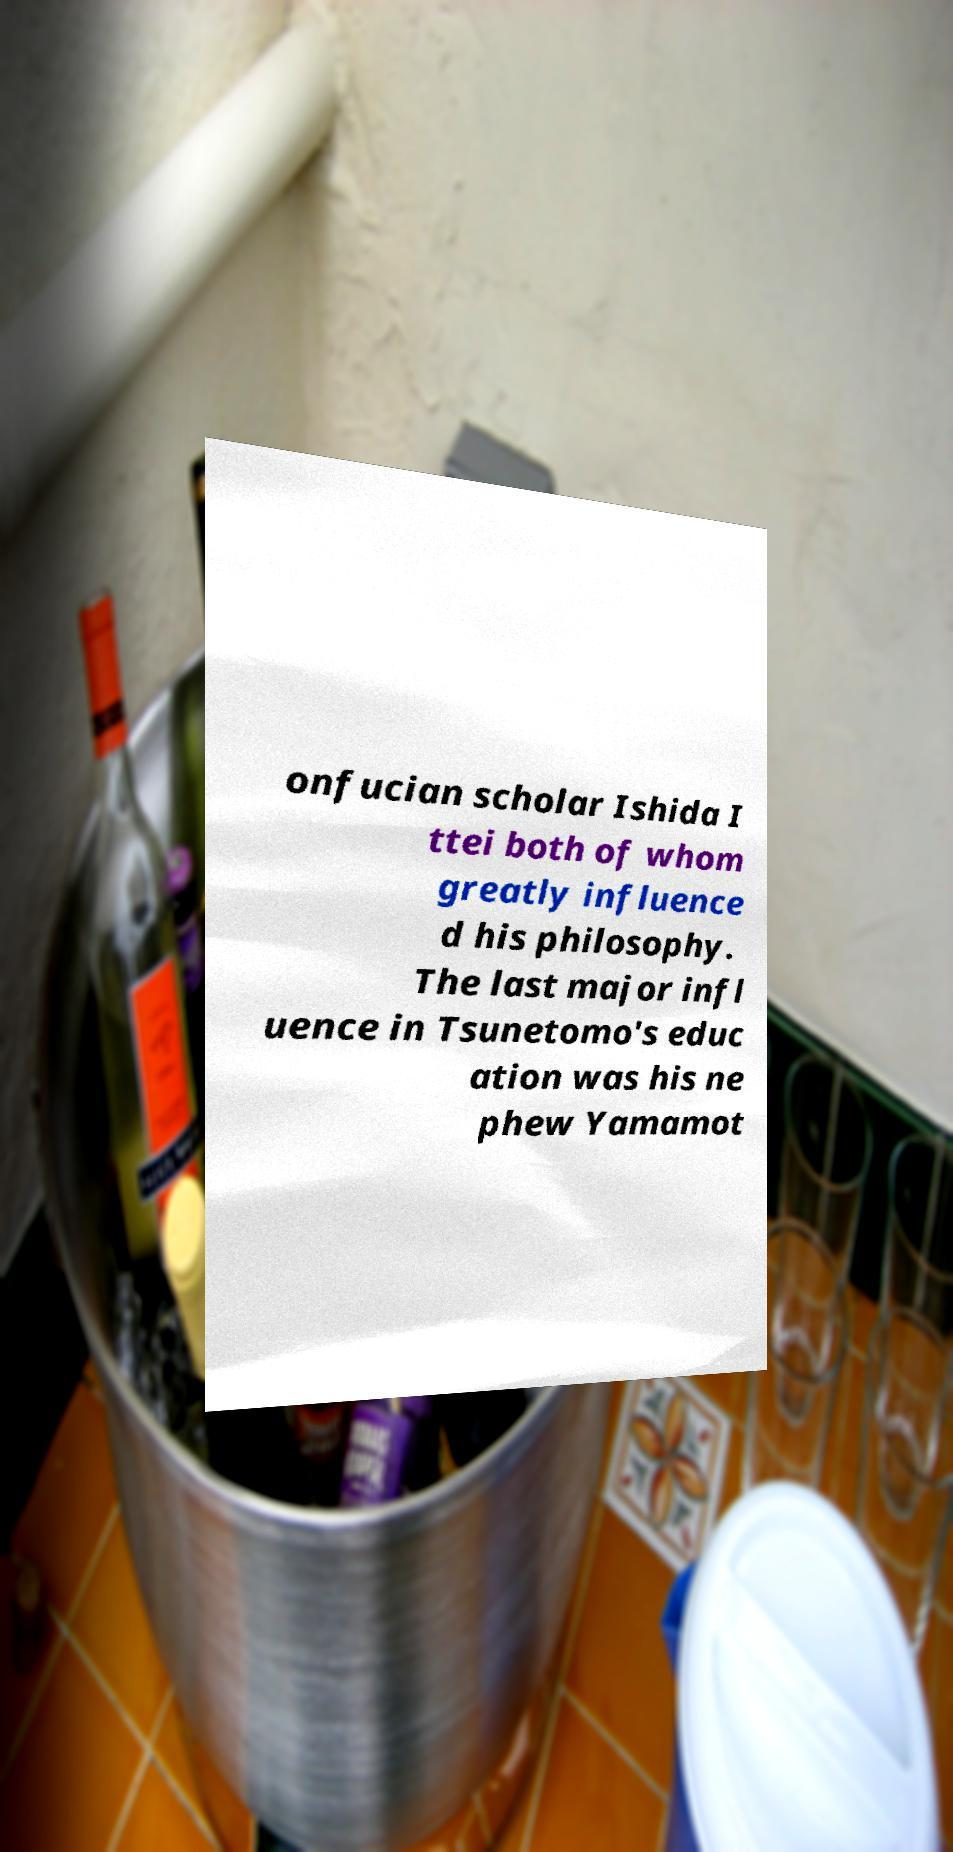Can you read and provide the text displayed in the image?This photo seems to have some interesting text. Can you extract and type it out for me? onfucian scholar Ishida I ttei both of whom greatly influence d his philosophy. The last major infl uence in Tsunetomo's educ ation was his ne phew Yamamot 